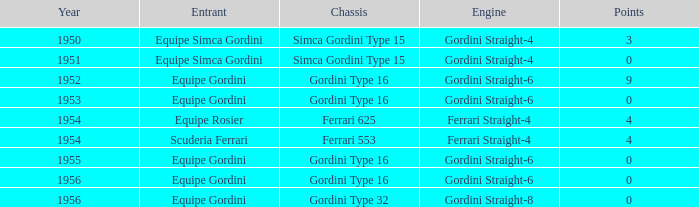Before 1956, what Chassis has Gordini Straight-4 engine with 3 points? Simca Gordini Type 15. 